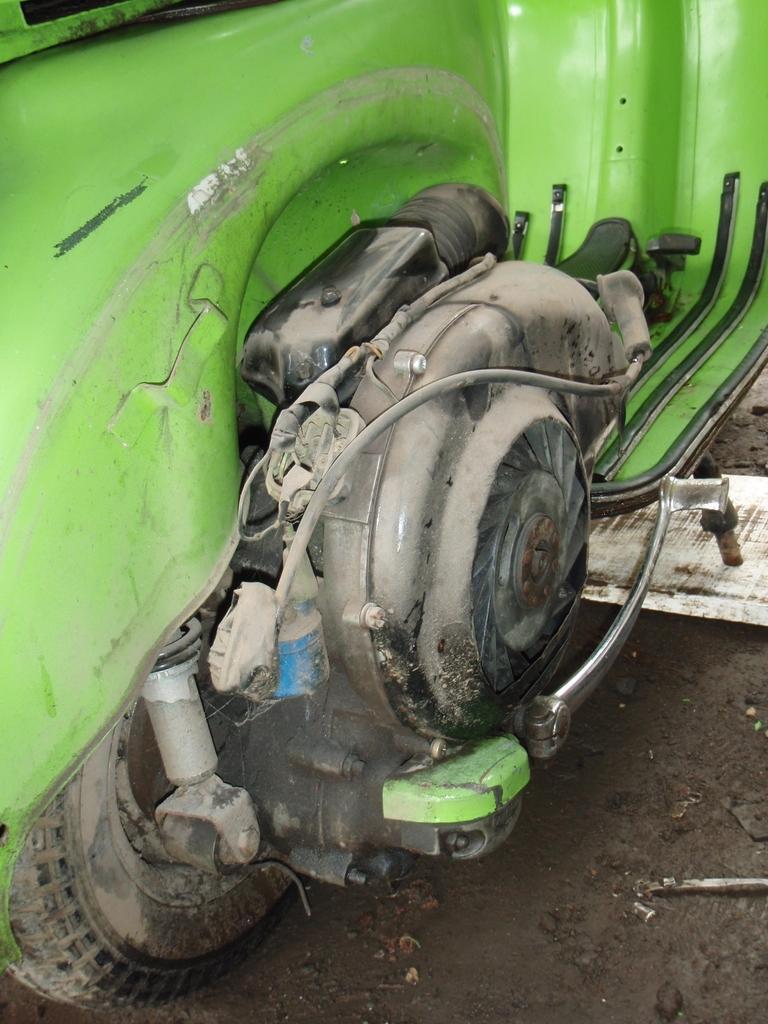How would you summarize this image in a sentence or two? This picture shows a scooter. It is green in color. 